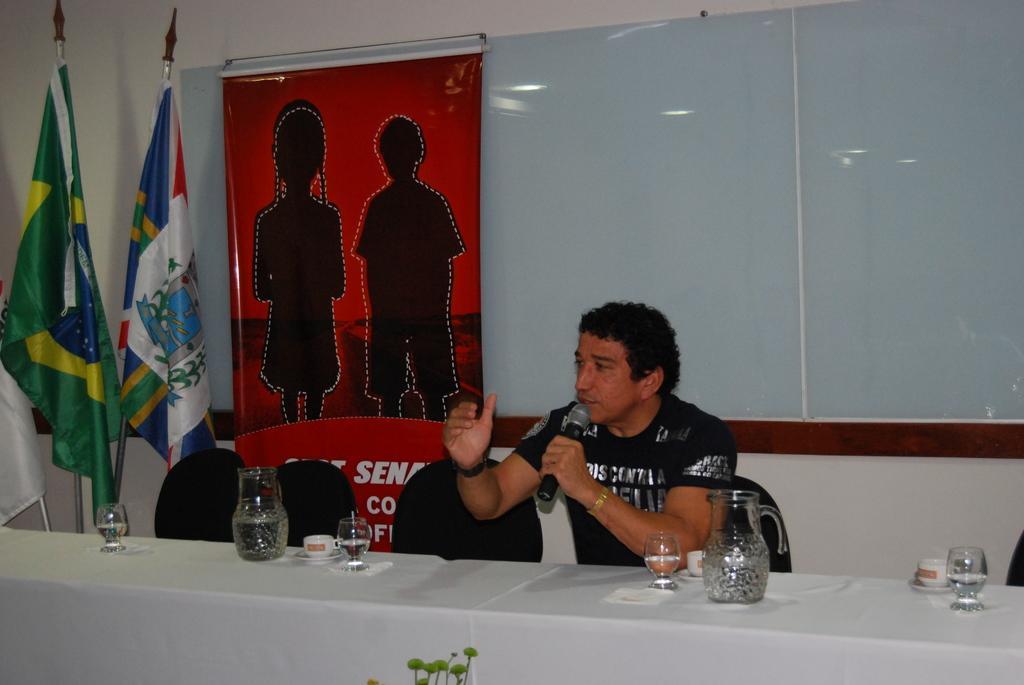Can you describe this image briefly? In the middle of the image a man is sitting a man is sitting and holding a microphone and talking. Behind him there is a board and there is a banner. Top left side of the image there are two flags. Bottom of the image there is a table, On the table there are some jars and glasses and cups. Top of the image there is a wall. 